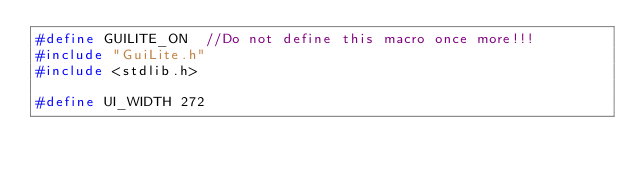Convert code to text. <code><loc_0><loc_0><loc_500><loc_500><_C++_>#define GUILITE_ON  //Do not define this macro once more!!!
#include "GuiLite.h"
#include <stdlib.h>

#define UI_WIDTH 272</code> 